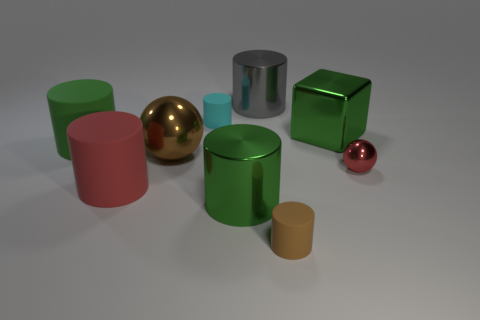What shape is the tiny brown matte object?
Give a very brief answer. Cylinder. How many brown things are either big spheres or tiny shiny cylinders?
Provide a succinct answer. 1. There is a cyan thing that is made of the same material as the large red thing; what is its size?
Provide a short and direct response. Small. Is the big thing on the right side of the gray cylinder made of the same material as the tiny cylinder that is behind the green rubber cylinder?
Offer a very short reply. No. How many cylinders are gray objects or big objects?
Make the answer very short. 4. There is a green metallic object left of the tiny cylinder in front of the big red matte cylinder; what number of large red objects are to the left of it?
Your response must be concise. 1. There is a large gray thing that is the same shape as the green matte object; what is it made of?
Your response must be concise. Metal. Is there anything else that is the same material as the small cyan cylinder?
Offer a very short reply. Yes. There is a small cylinder to the right of the cyan cylinder; what is its color?
Ensure brevity in your answer.  Brown. Does the tiny brown cylinder have the same material as the small cylinder that is on the left side of the gray cylinder?
Give a very brief answer. Yes. 